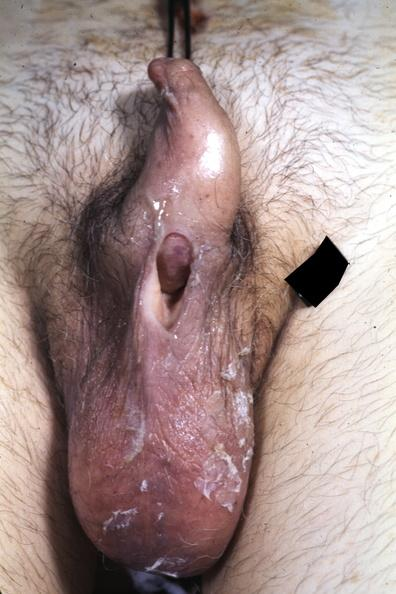s section of both kidneys and adrenals present?
Answer the question using a single word or phrase. No 